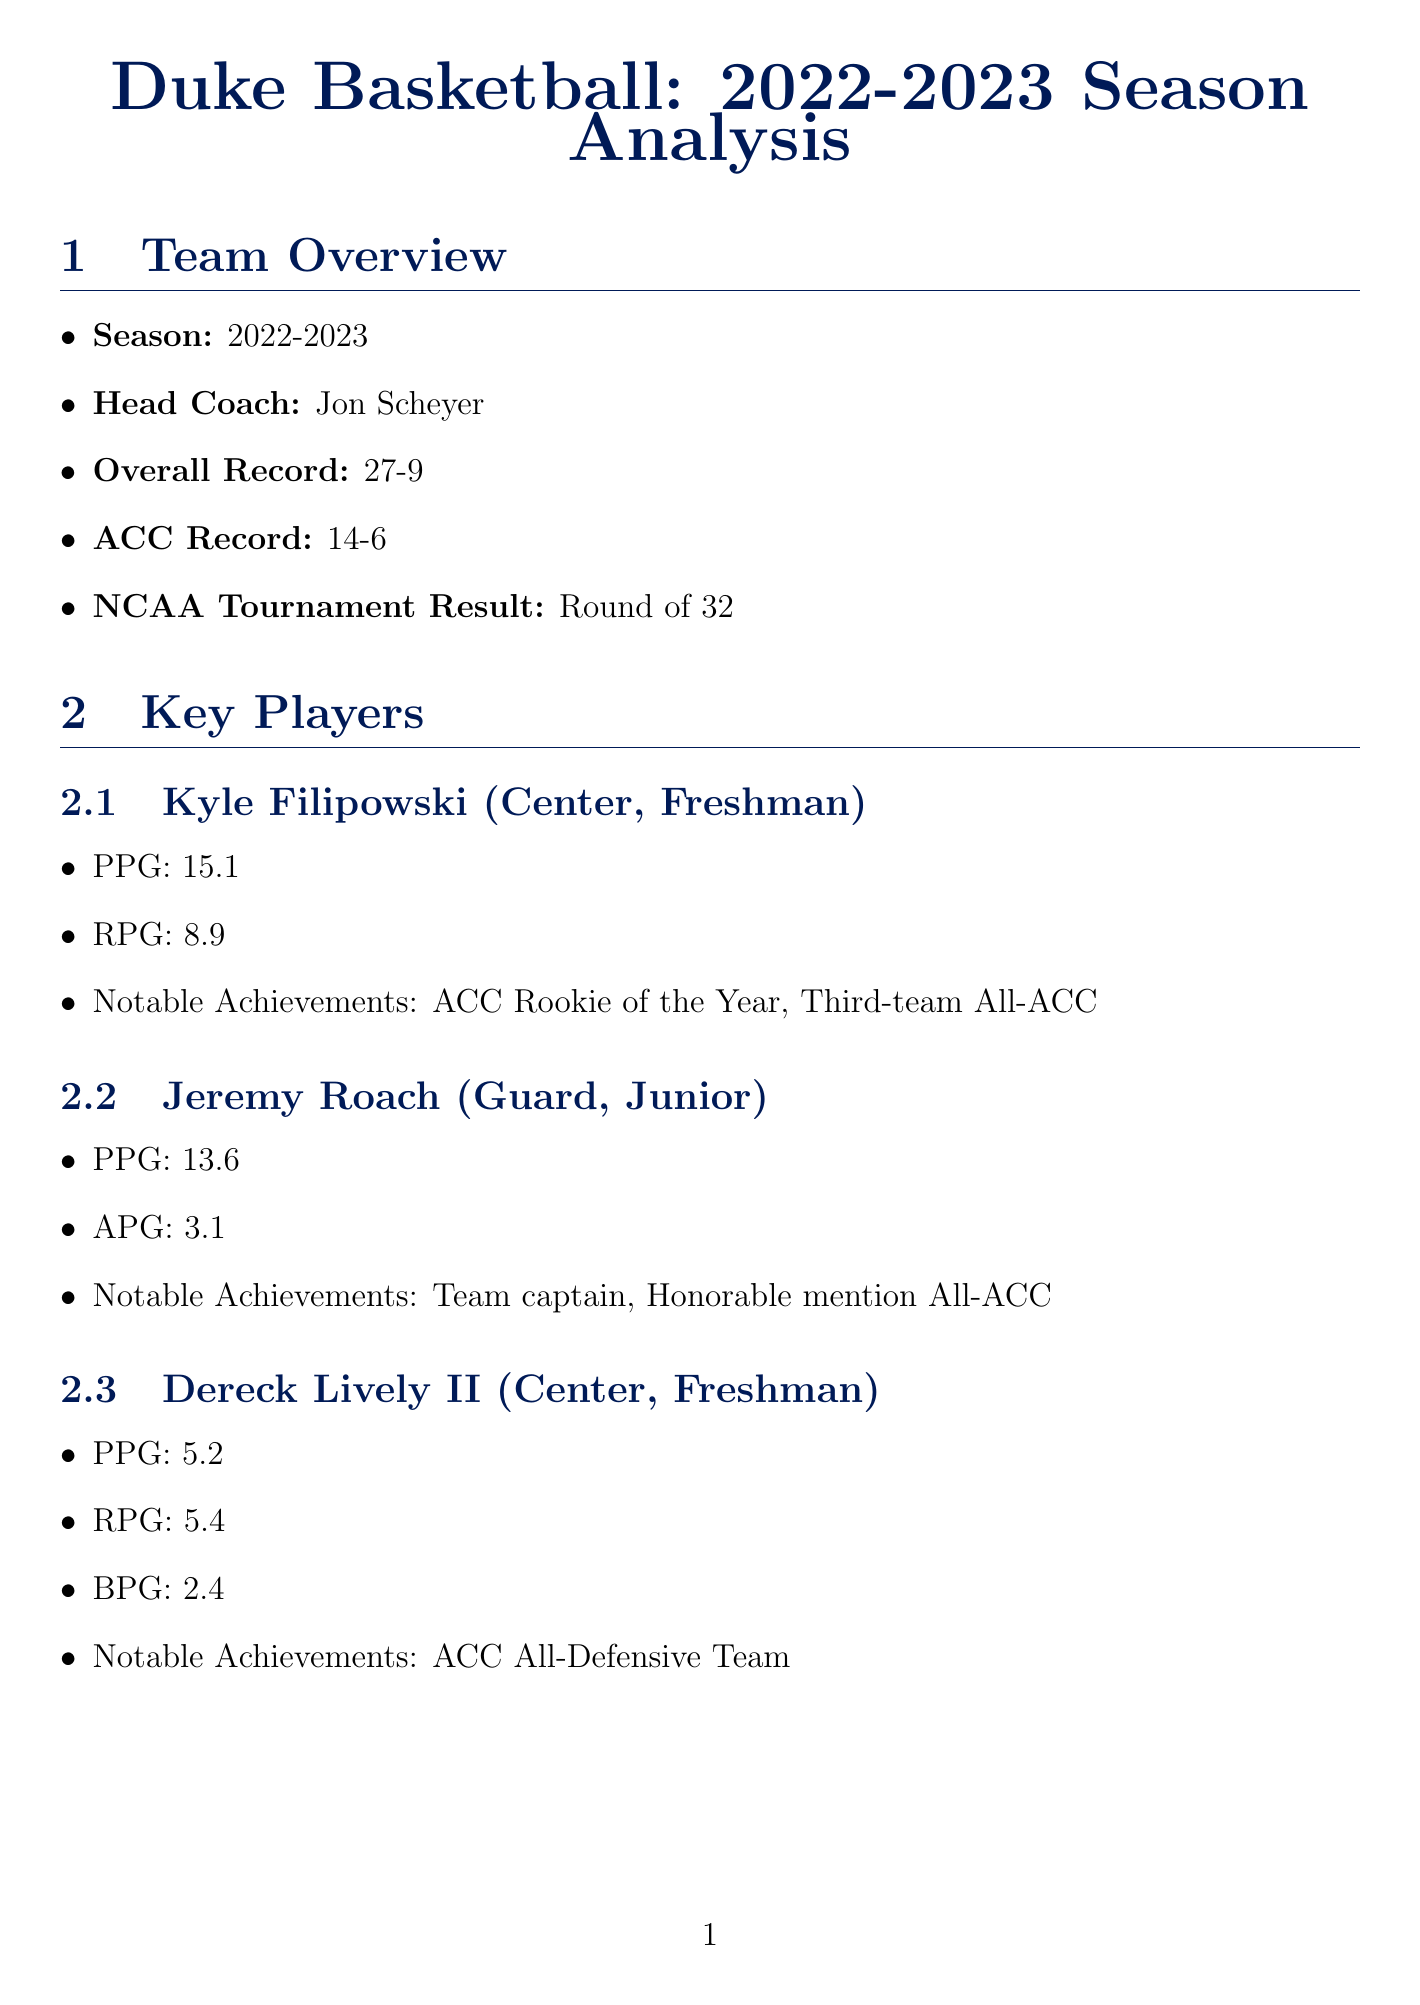What is Duke's overall record for the 2022-2023 season? The overall record is listed in the team overview section of the document as 27 wins and 9 losses.
Answer: 27-9 Who was named ACC Rookie of the Year? This title is attributed to Kyle Filipowski in the key players section of the document.
Answer: Kyle Filipowski What is the team's three-point percentage? The document specifies the three-point shooting percentage in the team statistics section, which is a critical metric for evaluating shooting efficiency.
Answer: 33.5% Which key player recorded a double-double against Virginia? The document highlights Kyle Filipowski's performance in that game in the notable games section.
Answer: Kyle Filipowski What is one of the team's weaknesses mentioned in the season analysis? The weaknesses are discussed in the season analysis section and include issues such as inconsistent shooting.
Answer: Inconsistent three-point shooting What was the outcome of the game against North Carolina? The result is detailed in the notable games section, highlighting a significant rivalry match.
Answer: Win (63-57) What is the primary focus of the physics connection in the document? The physics connection relates to analyzing shooting trajectories, which incorporates principles of motion.
Answer: Projectile motion Who are two of the returning players for the next season? The section on returning players lists specific individuals expected to return, indicating continuity in the team for the following season.
Answer: Jeremy Roach, Mark Mitchell 